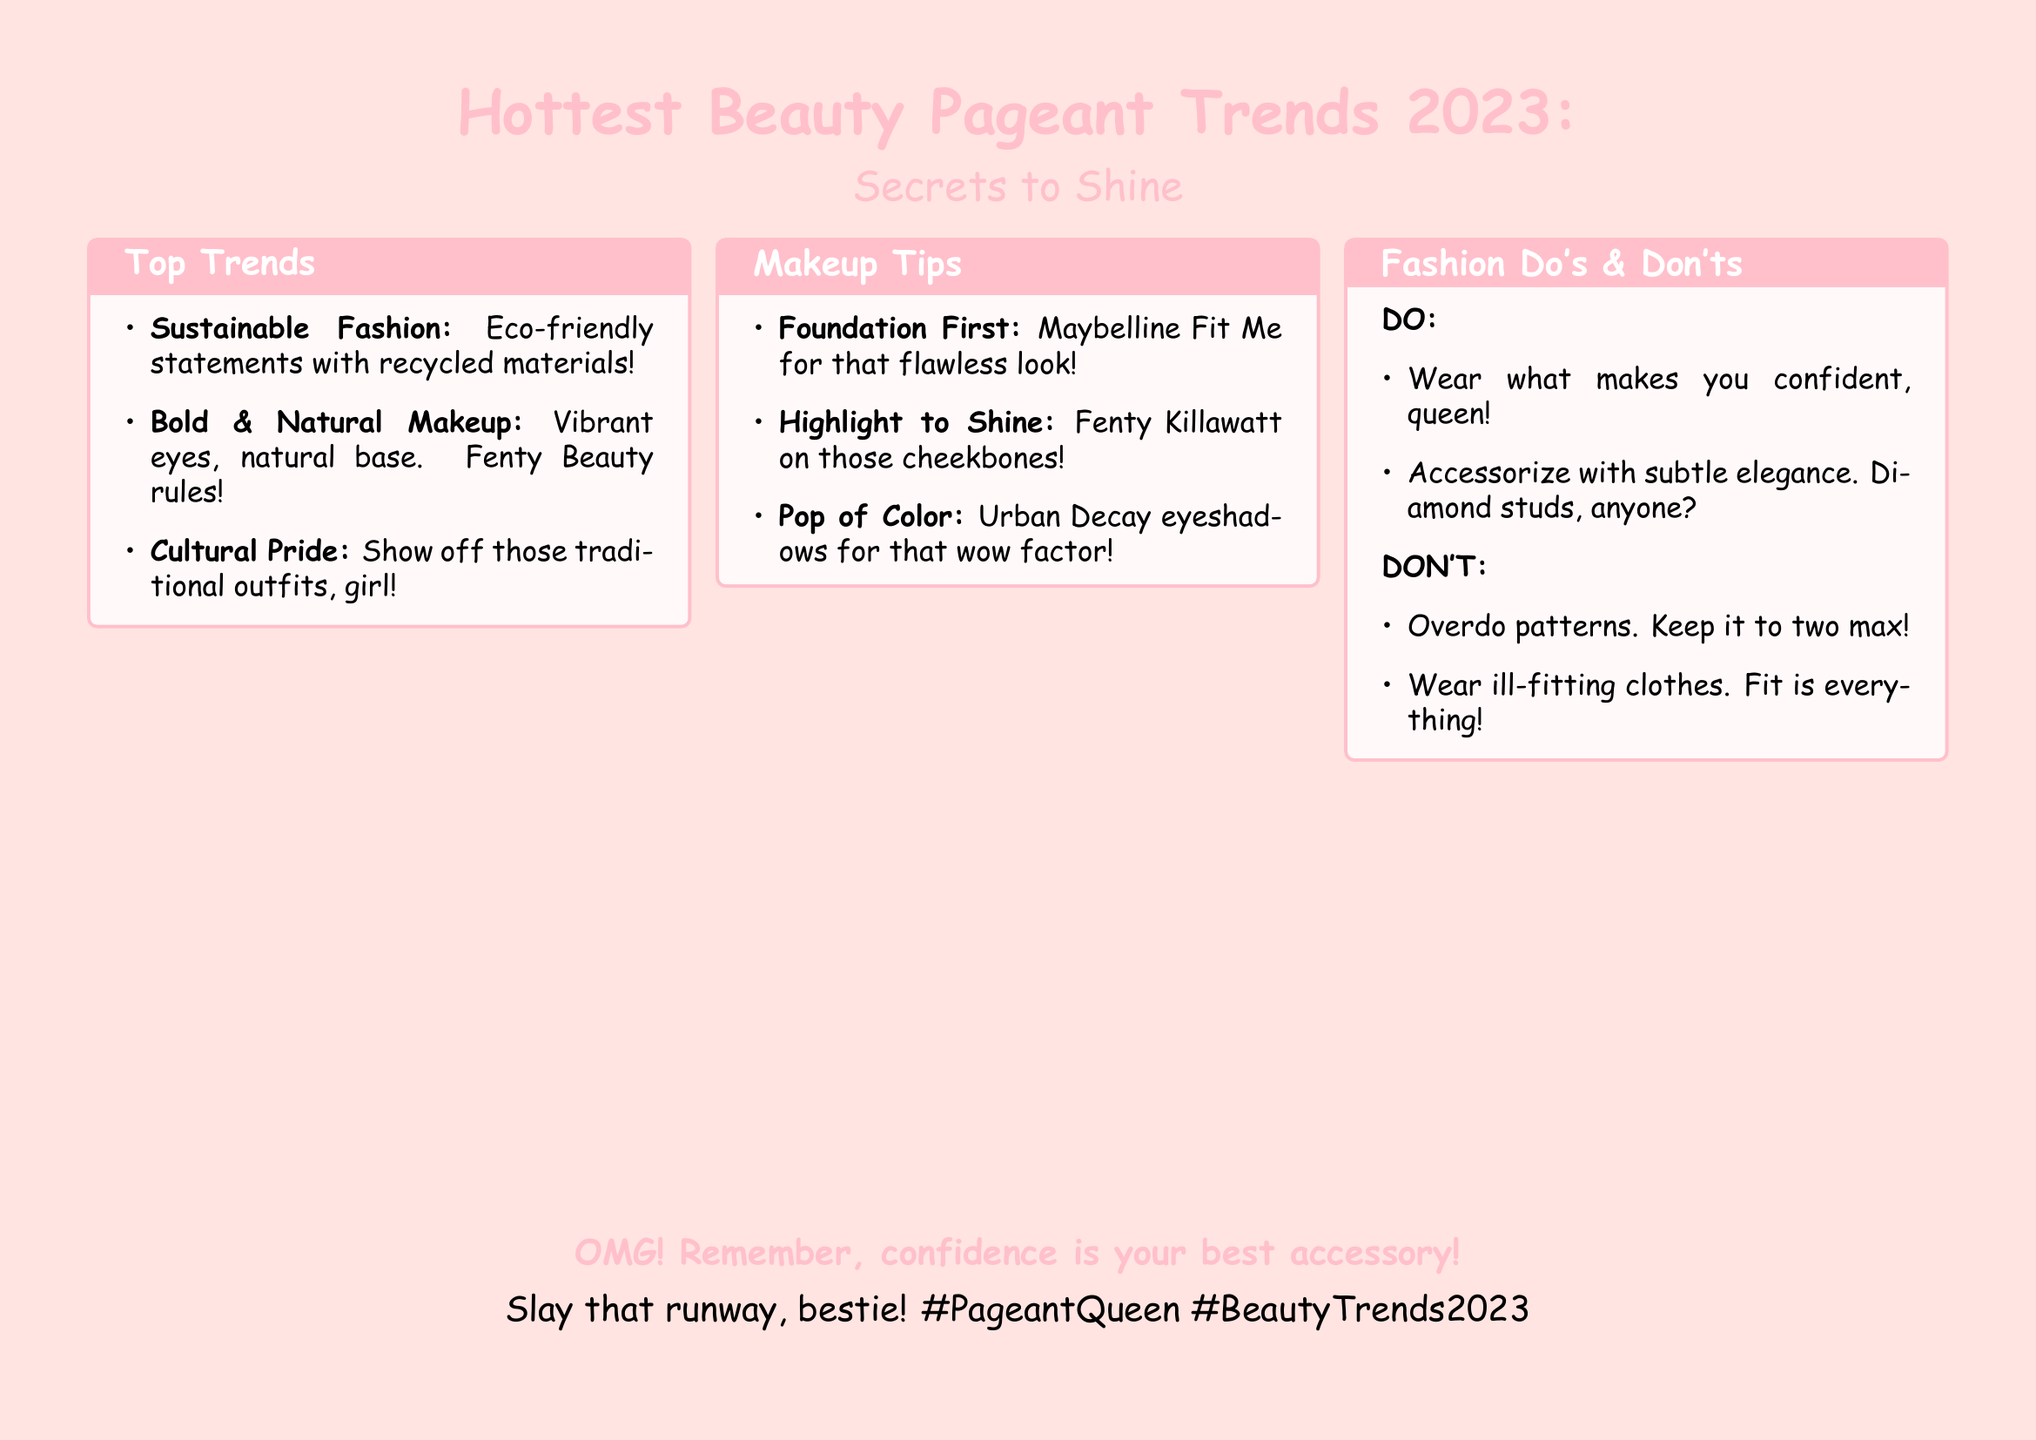What are the top trends listed? The document lists the top trends in beauty pageantry, which include sustainable fashion, bold and natural makeup, and cultural pride.
Answer: Sustainable Fashion, Bold & Natural Makeup, Cultural Pride What makeup brand is recommended for a flawless look? The flyer specifies the Maybelline Fit Me foundation as the recommended product for achieving a flawless appearance.
Answer: Maybelline Fit Me What should you apply on your cheekbones to shine? The document recommends using Fenty Killawatt for highlighting cheekbones.
Answer: Fenty Killawatt What is a fashion "do" according to the flyer? The flyer advises that wearing something that makes you confident is a fashion "do."
Answer: Wear what makes you confident What is a fashion "don't" mentioned in the document? The of the flyer clearly states that one should not wear ill-fitting clothes, marking it as a fashion "don't."
Answer: Wear ill-fitting clothes How many patterns should you keep it to? The document mentions that it is best to keep patterns to two at a maximum.
Answer: Two What makeup product is suggested for vibrant eyes? According to the flyer, Urban Decay is recommended for achieving a pop of color in eye makeup.
Answer: Urban Decay What color is predominantly featured in the flyer’s theme? The document prominently features pink as the main color throughout the design.
Answer: Pink What is the overall theme of this document? The flyer conveys the theme of highlighting the latest trends and tips in beauty pageantry for 2023.
Answer: Hottest Beauty Pageant Trends 2023 